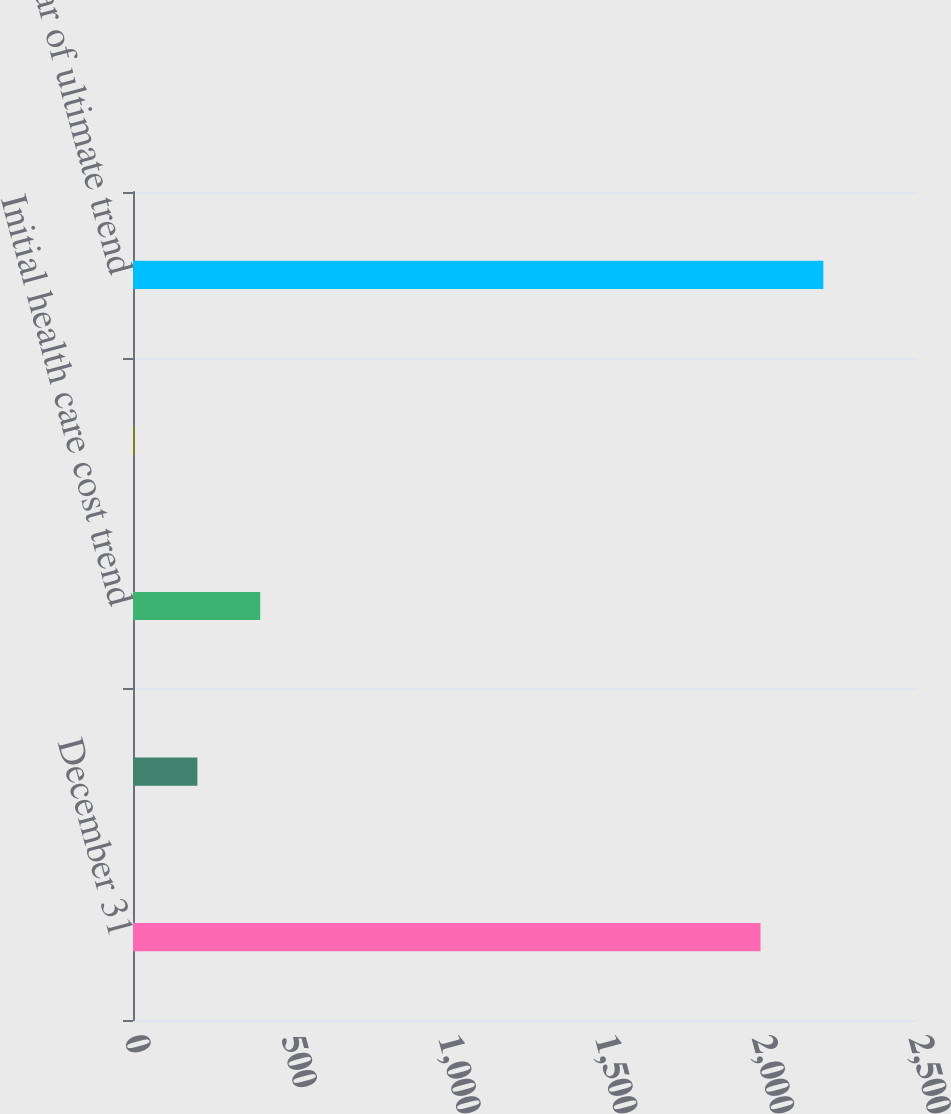Convert chart to OTSL. <chart><loc_0><loc_0><loc_500><loc_500><bar_chart><fcel>December 31<fcel>Discount rate<fcel>Initial health care cost trend<fcel>Ultimate health care cost<fcel>First year of ultimate trend<nl><fcel>2001<fcel>205.3<fcel>405.6<fcel>5<fcel>2201.3<nl></chart> 